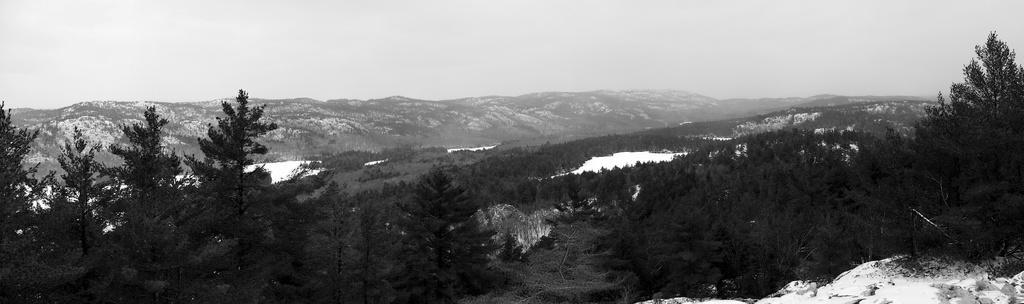Could you give a brief overview of what you see in this image? In this image we can see there is a snow, trees, mountains and sky. 